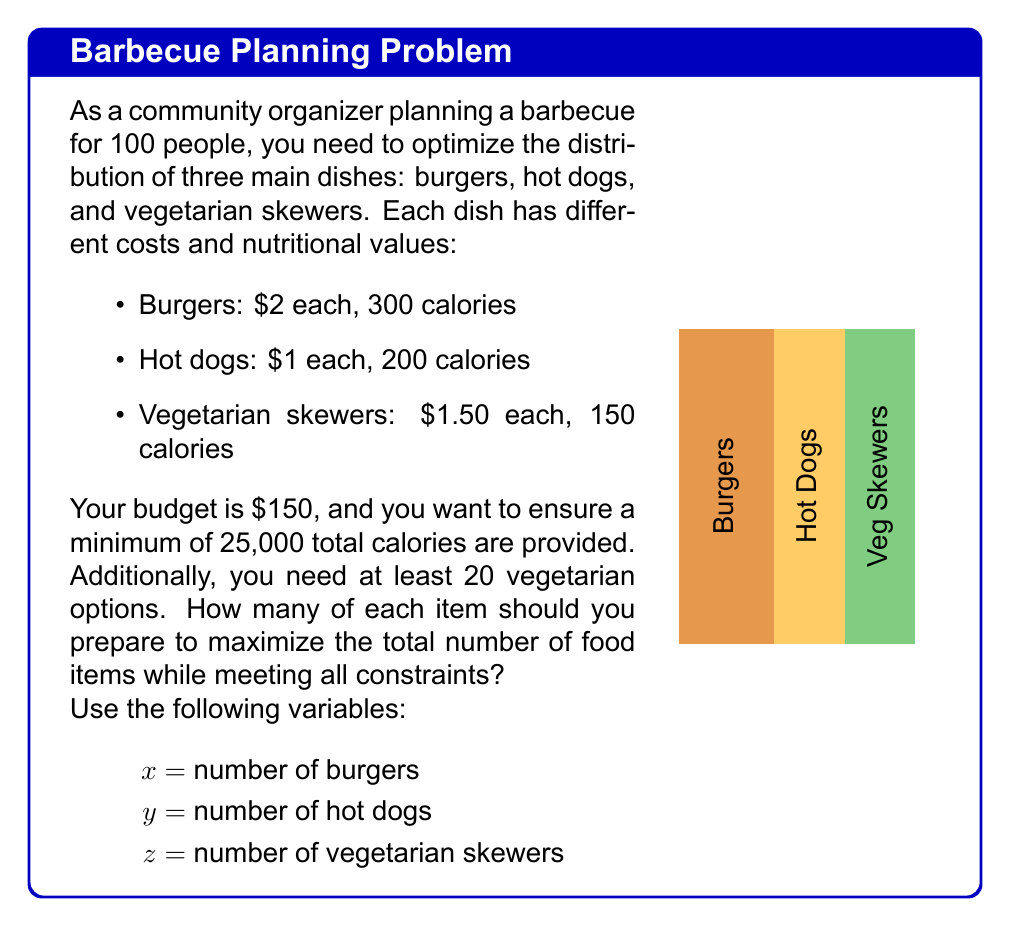Give your solution to this math problem. Let's approach this problem step-by-step using linear programming:

1) Objective function: Maximize the total number of food items
   $$\text{Maximize } Z = x + y + z$$

2) Constraints:
   a) Budget constraint: $$2x + y + 1.5z \leq 150$$
   b) Calorie constraint: $$300x + 200y + 150z \geq 25000$$
   c) Vegetarian option constraint: $$z \geq 20$$
   d) Non-negativity constraints: $$x, y, z \geq 0$$

3) We can solve this using the simplex method or linear programming software. However, for this explanation, let's use a graphical approach and reasoning.

4) From the vegetarian constraint, we know $z = 20$ is the minimum. Let's start there.

5) Substituting $z = 20$ into the budget constraint:
   $$2x + y + 1.5(20) \leq 150$$
   $$2x + y \leq 120$$

6) Substituting $z = 20$ into the calorie constraint:
   $$300x + 200y + 150(20) \geq 25000$$
   $$300x + 200y \geq 22000$$

7) Now we have a 2D problem. The feasible region is the area that satisfies both these inequalities.

8) The optimal solution will be at a corner point of this feasible region. Let's find the intersection of these lines:
   $$2x + y = 120$$
   $$300x + 200y = 22000$$

9) Solving these equations:
   $$x = 40, y = 40$$

10) Therefore, the optimal solution is:
    $$x = 40 \text{ (burgers)}$$
    $$y = 40 \text{ (hot dogs)}$$
    $$z = 20 \text{ (vegetarian skewers)}$$

11) We can verify that this solution satisfies all constraints:
    - Budget: $2(40) + 1(40) + 1.5(20) = 150$
    - Calories: $300(40) + 200(40) + 150(20) = 25000$
    - Vegetarian options: 20 ≥ 20
    - Total items: 40 + 40 + 20 = 100

This solution maximizes the total number of food items (100) while meeting all constraints.
Answer: 40 burgers, 40 hot dogs, 20 vegetarian skewers 